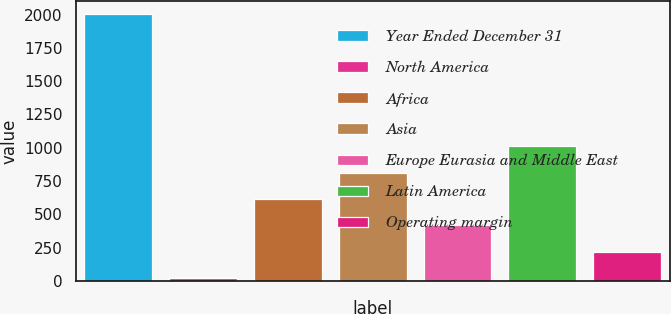Convert chart to OTSL. <chart><loc_0><loc_0><loc_500><loc_500><bar_chart><fcel>Year Ended December 31<fcel>North America<fcel>Africa<fcel>Asia<fcel>Europe Eurasia and Middle East<fcel>Latin America<fcel>Operating margin<nl><fcel>2003<fcel>20.2<fcel>615.04<fcel>813.32<fcel>416.76<fcel>1011.6<fcel>218.48<nl></chart> 